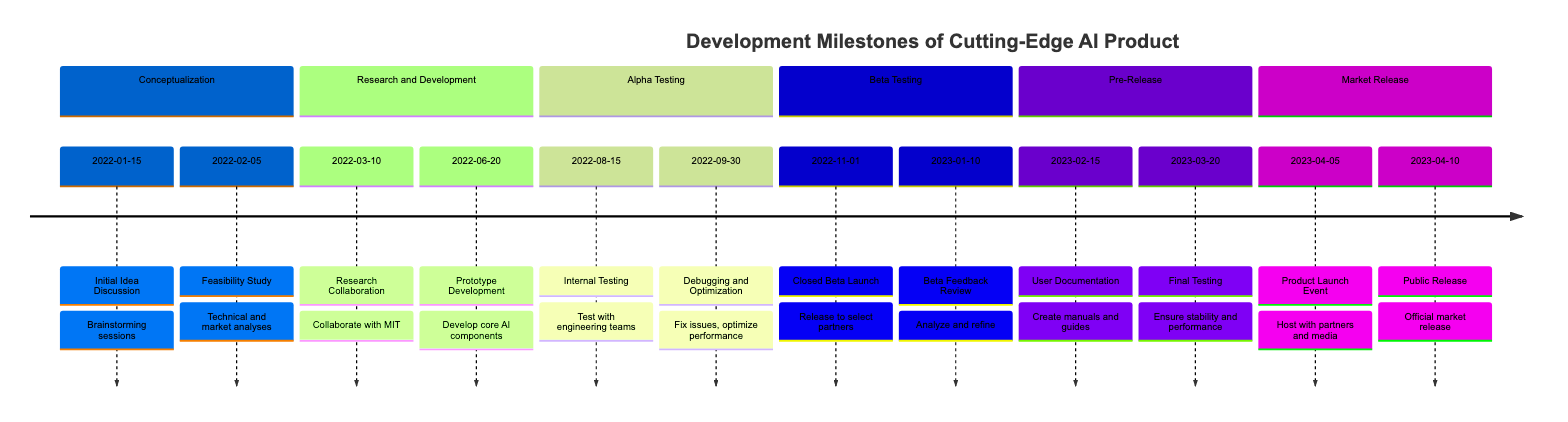what is the date of the Initial Idea Discussion? The timeline indicates that the Initial Idea Discussion took place on January 15, 2022, as it appears at the beginning of the Conceptualization phase.
Answer: January 15, 2022 how many phases are there in total? The timeline comprises six distinct phases: Conceptualization, Research and Development, Alpha Testing, Beta Testing, Pre-Release, and Market Release. By counting these phases, we find there are six.
Answer: 6 what milestone comes after Debugging and Optimization? According to the timeline, the next milestone after Debugging and Optimization, which occurred on September 30, 2022, is Closed Beta Launch on November 1, 2022. This links the two milestones as they occur in succession.
Answer: Closed Beta Launch which phase includes the Prototype Development milestone? The Prototype Development milestone falls under the Research and Development phase, as indicated in the timeline where it lists milestones particular to that phase.
Answer: Research and Development what was the focus of the User Documentation milestone? The User Documentation milestone focused on creating comprehensive user manuals and integration guides, as specified in the description next to this milestone in the Pre-Release section of the timeline.
Answer: Creating user manuals and integration guides which milestone occurred last? The last milestone shown on the timeline is the Public Release, which officially released the product to the market on April 10, 2023. By examining the order of milestones, it is clear that this is positioned at the end of the timeline.
Answer: Public Release how long was the Beta Feedback Review phase after Closed Beta Launch? The Closed Beta Launch occurred on November 1, 2022, followed by the Beta Feedback Review on January 10, 2023. This indicates a duration of about two months and ten days between these two milestones.
Answer: Two months and ten days which organization provided feedback during Closed Beta Launch? The timeline specifies that feedback during the Closed Beta Launch was gathered from select partner organizations like Google. This information directly correlates with the description provided for that milestone.
Answer: Google 